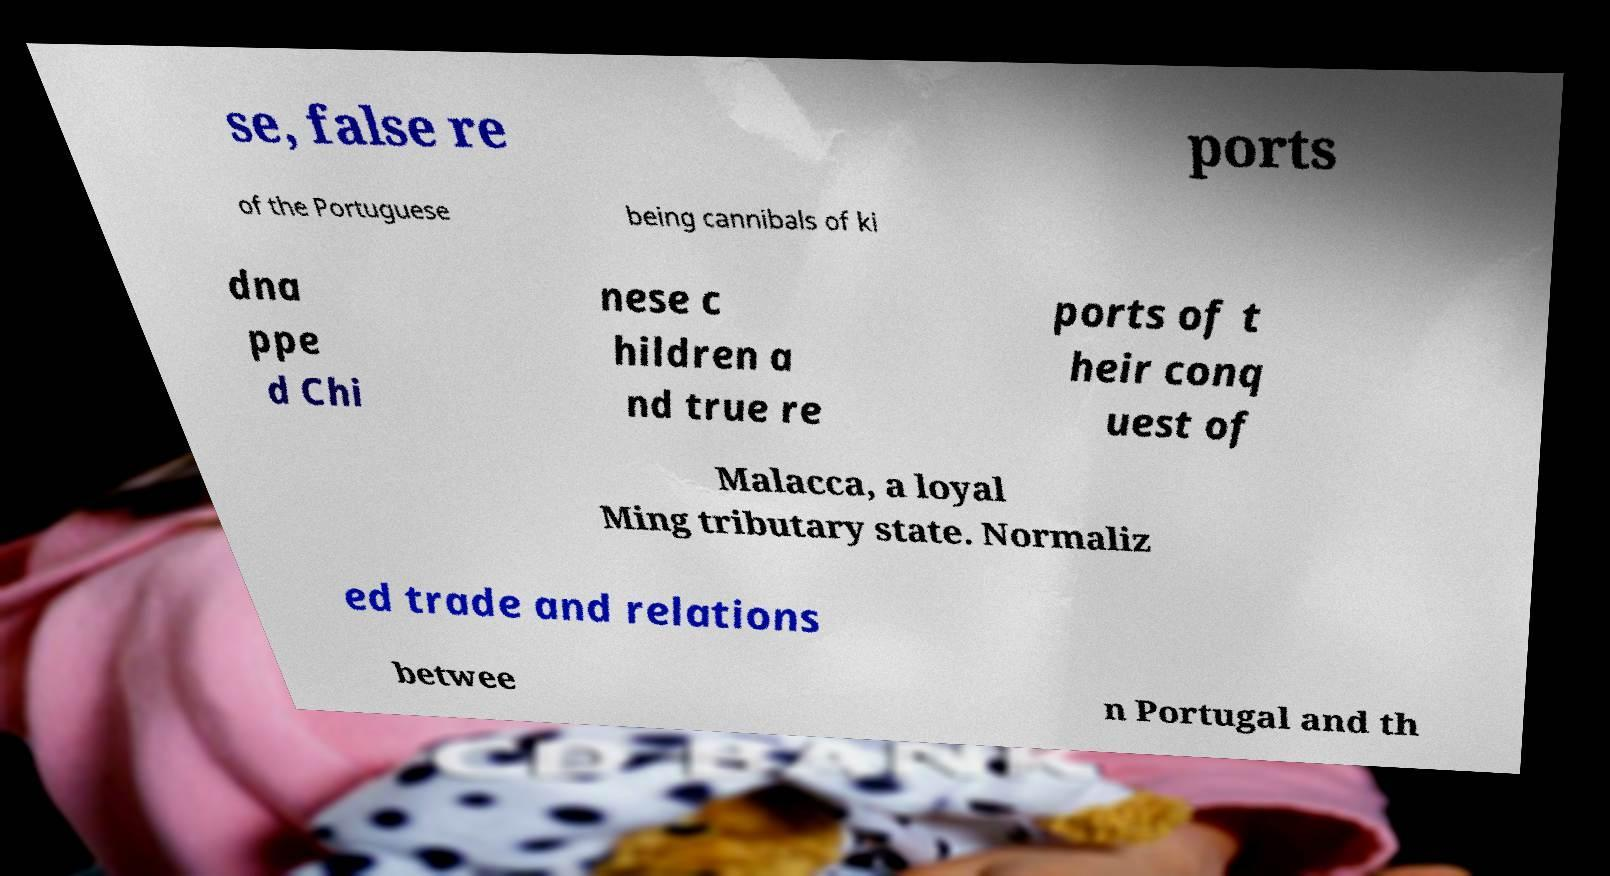Could you extract and type out the text from this image? se, false re ports of the Portuguese being cannibals of ki dna ppe d Chi nese c hildren a nd true re ports of t heir conq uest of Malacca, a loyal Ming tributary state. Normaliz ed trade and relations betwee n Portugal and th 